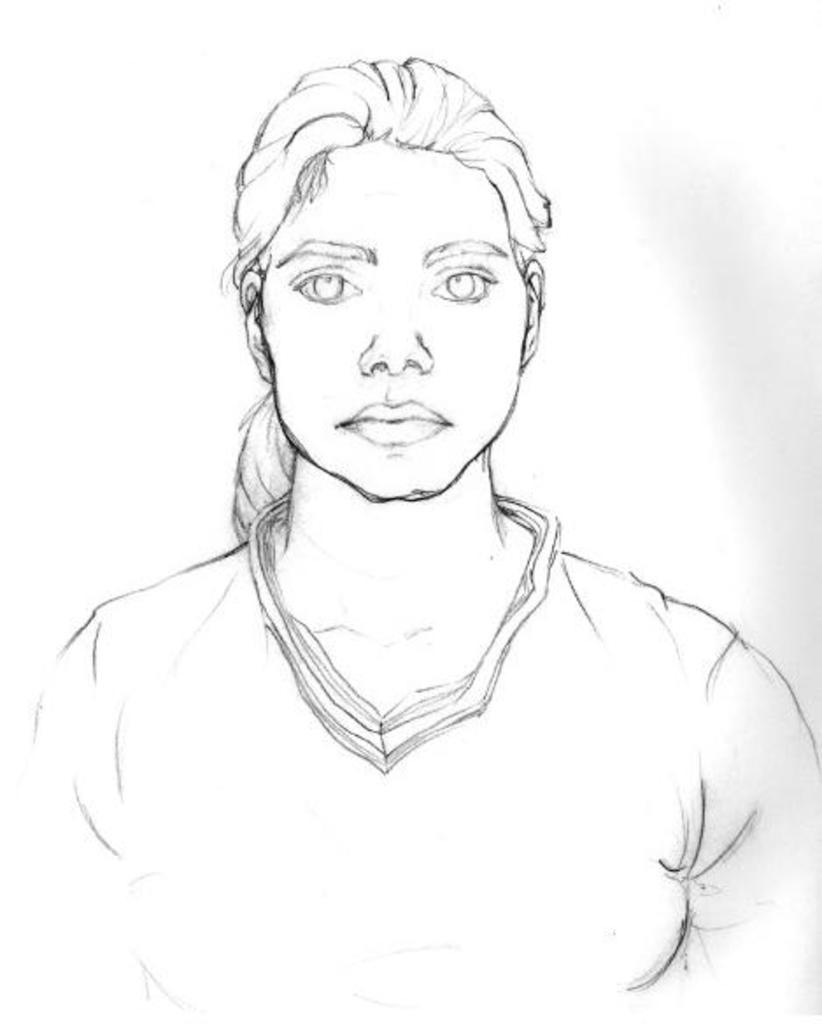How would you summarize this image in a sentence or two? In this picture I can see sketch of a woman and I can see white background. 